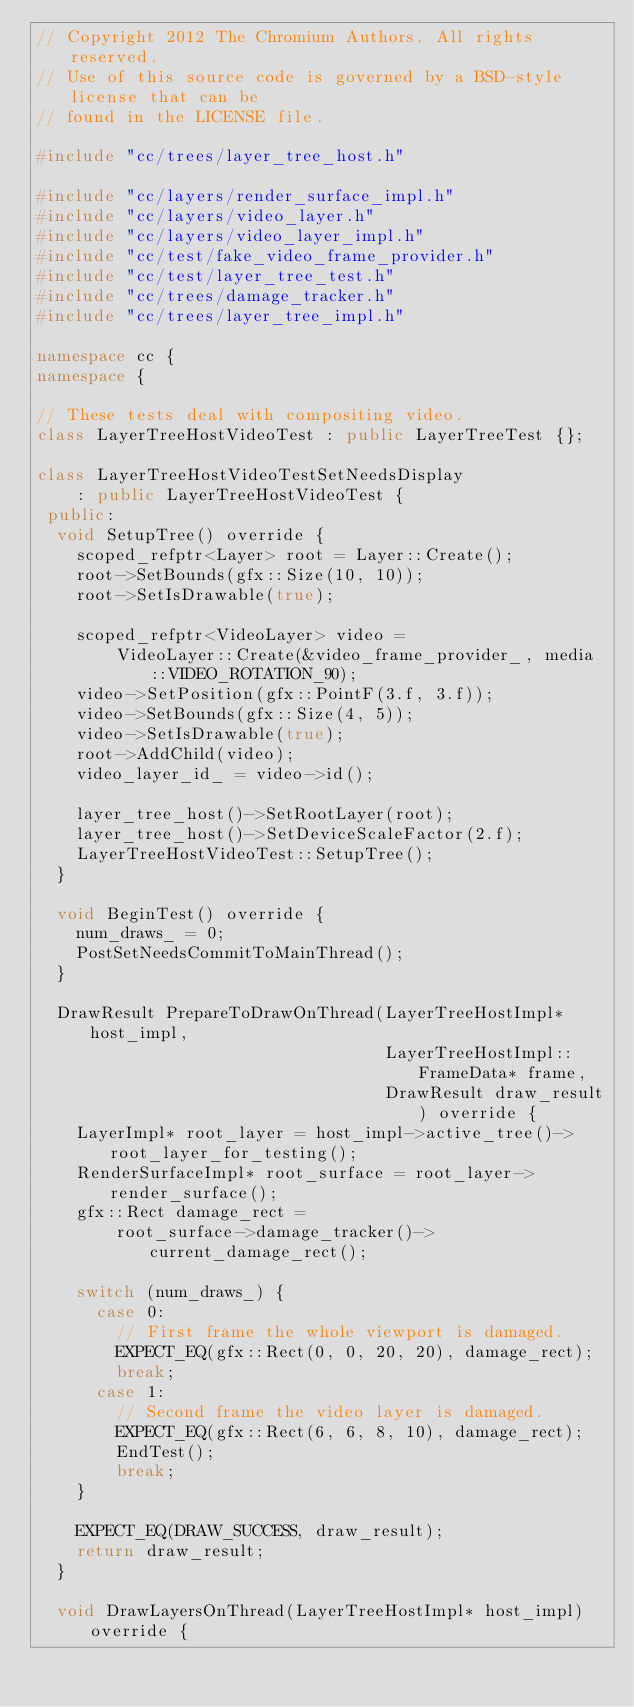<code> <loc_0><loc_0><loc_500><loc_500><_C++_>// Copyright 2012 The Chromium Authors. All rights reserved.
// Use of this source code is governed by a BSD-style license that can be
// found in the LICENSE file.

#include "cc/trees/layer_tree_host.h"

#include "cc/layers/render_surface_impl.h"
#include "cc/layers/video_layer.h"
#include "cc/layers/video_layer_impl.h"
#include "cc/test/fake_video_frame_provider.h"
#include "cc/test/layer_tree_test.h"
#include "cc/trees/damage_tracker.h"
#include "cc/trees/layer_tree_impl.h"

namespace cc {
namespace {

// These tests deal with compositing video.
class LayerTreeHostVideoTest : public LayerTreeTest {};

class LayerTreeHostVideoTestSetNeedsDisplay
    : public LayerTreeHostVideoTest {
 public:
  void SetupTree() override {
    scoped_refptr<Layer> root = Layer::Create();
    root->SetBounds(gfx::Size(10, 10));
    root->SetIsDrawable(true);

    scoped_refptr<VideoLayer> video =
        VideoLayer::Create(&video_frame_provider_, media::VIDEO_ROTATION_90);
    video->SetPosition(gfx::PointF(3.f, 3.f));
    video->SetBounds(gfx::Size(4, 5));
    video->SetIsDrawable(true);
    root->AddChild(video);
    video_layer_id_ = video->id();

    layer_tree_host()->SetRootLayer(root);
    layer_tree_host()->SetDeviceScaleFactor(2.f);
    LayerTreeHostVideoTest::SetupTree();
  }

  void BeginTest() override {
    num_draws_ = 0;
    PostSetNeedsCommitToMainThread();
  }

  DrawResult PrepareToDrawOnThread(LayerTreeHostImpl* host_impl,
                                   LayerTreeHostImpl::FrameData* frame,
                                   DrawResult draw_result) override {
    LayerImpl* root_layer = host_impl->active_tree()->root_layer_for_testing();
    RenderSurfaceImpl* root_surface = root_layer->render_surface();
    gfx::Rect damage_rect =
        root_surface->damage_tracker()->current_damage_rect();

    switch (num_draws_) {
      case 0:
        // First frame the whole viewport is damaged.
        EXPECT_EQ(gfx::Rect(0, 0, 20, 20), damage_rect);
        break;
      case 1:
        // Second frame the video layer is damaged.
        EXPECT_EQ(gfx::Rect(6, 6, 8, 10), damage_rect);
        EndTest();
        break;
    }

    EXPECT_EQ(DRAW_SUCCESS, draw_result);
    return draw_result;
  }

  void DrawLayersOnThread(LayerTreeHostImpl* host_impl) override {</code> 